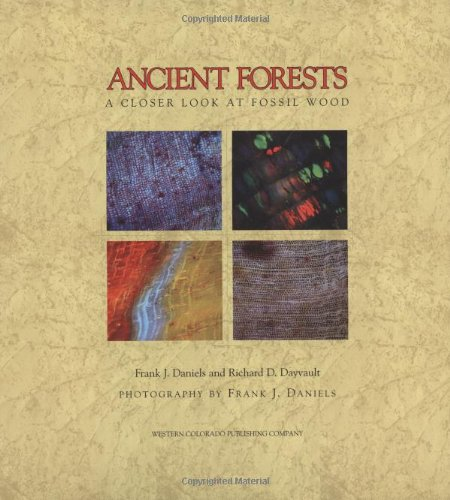What is the title of this book? The title of the book is 'Ancient Forests: A Closer Look at Fossil Wood,' which invites readers on a visual and scientific journey into the world of petrified wood and its historical significance. 